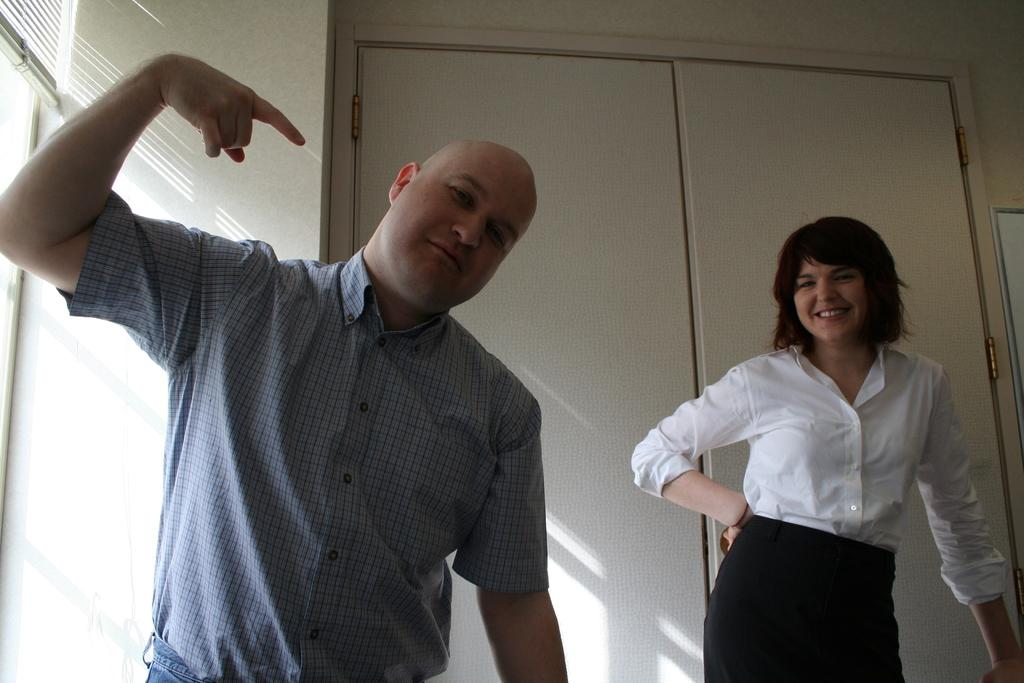What is the person on the left side of the image wearing? The person on the left side of the image is wearing a blue shirt. What can be seen in the image that allows light to enter or exit a room? There are windows and window blinds present in the image. What type of architectural feature is visible in the image? There is a wall in the image. What is the woman on the right side of the image wearing? The woman on the right side of the image is wearing a white shirt. What is located in the background of the image? There is a door in the background of the image. What type of range can be seen in the image? There is no range present in the image. Is there a snake visible in the image? No, there is no snake visible in the image. 